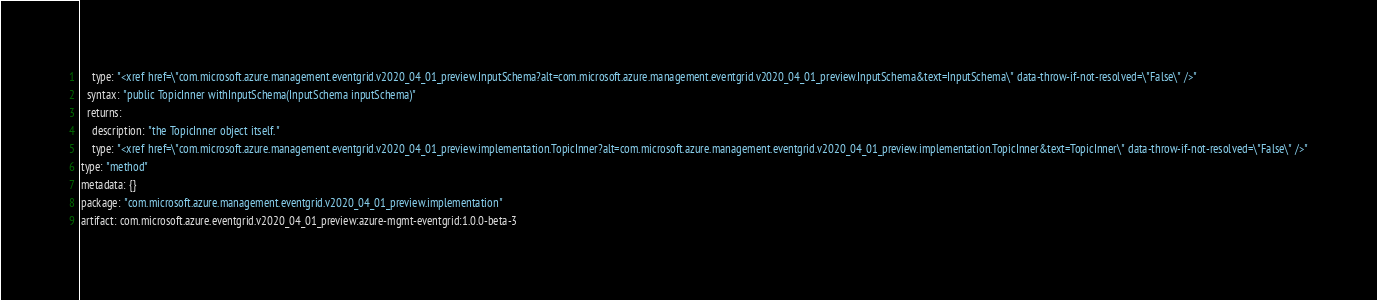Convert code to text. <code><loc_0><loc_0><loc_500><loc_500><_YAML_>    type: "<xref href=\"com.microsoft.azure.management.eventgrid.v2020_04_01_preview.InputSchema?alt=com.microsoft.azure.management.eventgrid.v2020_04_01_preview.InputSchema&text=InputSchema\" data-throw-if-not-resolved=\"False\" />"
  syntax: "public TopicInner withInputSchema(InputSchema inputSchema)"
  returns:
    description: "the TopicInner object itself."
    type: "<xref href=\"com.microsoft.azure.management.eventgrid.v2020_04_01_preview.implementation.TopicInner?alt=com.microsoft.azure.management.eventgrid.v2020_04_01_preview.implementation.TopicInner&text=TopicInner\" data-throw-if-not-resolved=\"False\" />"
type: "method"
metadata: {}
package: "com.microsoft.azure.management.eventgrid.v2020_04_01_preview.implementation"
artifact: com.microsoft.azure.eventgrid.v2020_04_01_preview:azure-mgmt-eventgrid:1.0.0-beta-3
</code> 